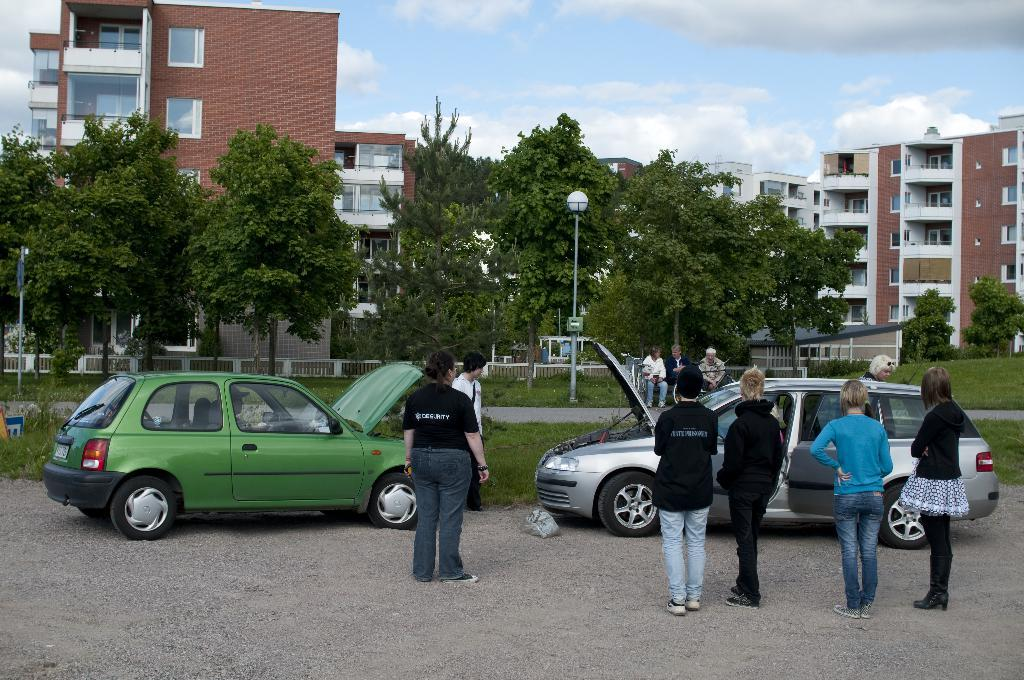What can be seen in the image related to transportation? There are many people standing near the cars in the image. What type of natural elements are present in the image? There are many trees in the image. What type of man-made structures can be seen in the image? There are buildings in the image. What is the condition of the sky in the image? The sky is clear and visible in the image. How many losses can be counted in the image? There is no indication of any losses in the image; it features people, trees, buildings, and a clear sky. What is the highest point in the image? The image does not have a specific highest point, as it is a scene with multiple elements at different heights. 